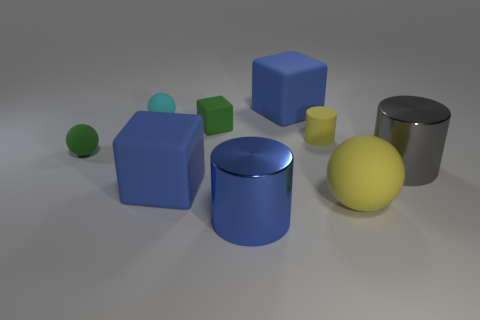What is the material of the yellow sphere that is the same size as the blue metallic object?
Ensure brevity in your answer.  Rubber. How many other things are there of the same material as the green block?
Keep it short and to the point. 6. Does the yellow object behind the gray cylinder have the same shape as the big blue matte object that is in front of the tiny cyan matte object?
Offer a terse response. No. Are the ball behind the small green cube and the sphere that is on the right side of the yellow rubber cylinder made of the same material?
Offer a very short reply. Yes. Are there the same number of metallic objects that are to the left of the small green rubber ball and big blue things that are in front of the gray metal cylinder?
Keep it short and to the point. No. There is a block in front of the gray metal cylinder; what is it made of?
Your answer should be compact. Rubber. Is there anything else that has the same size as the green rubber ball?
Provide a succinct answer. Yes. Is the number of green rubber balls less than the number of big blue rubber things?
Your answer should be very brief. Yes. The big matte thing that is both in front of the small yellow object and left of the small rubber cylinder has what shape?
Offer a very short reply. Cube. What number of large blue matte cubes are there?
Provide a short and direct response. 2. 